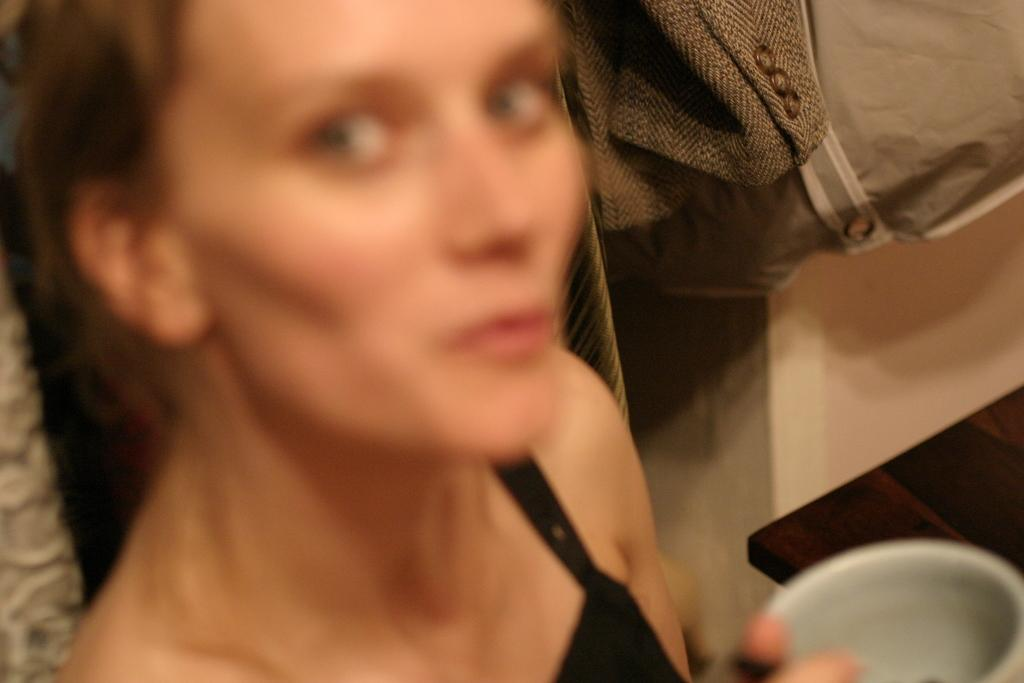Who is present in the image? There is a woman in the image. What is the woman wearing? The woman is wearing a black dress. What is the woman holding in the image? The woman is holding a cup. What piece of furniture can be seen in the image? There is a table in the image. Where is the cactus located in the image? There is no cactus present in the image. What type of jam is being served in the cup the woman is holding? The image does not provide information about the contents of the cup, so it cannot be determined if it contains jam. 